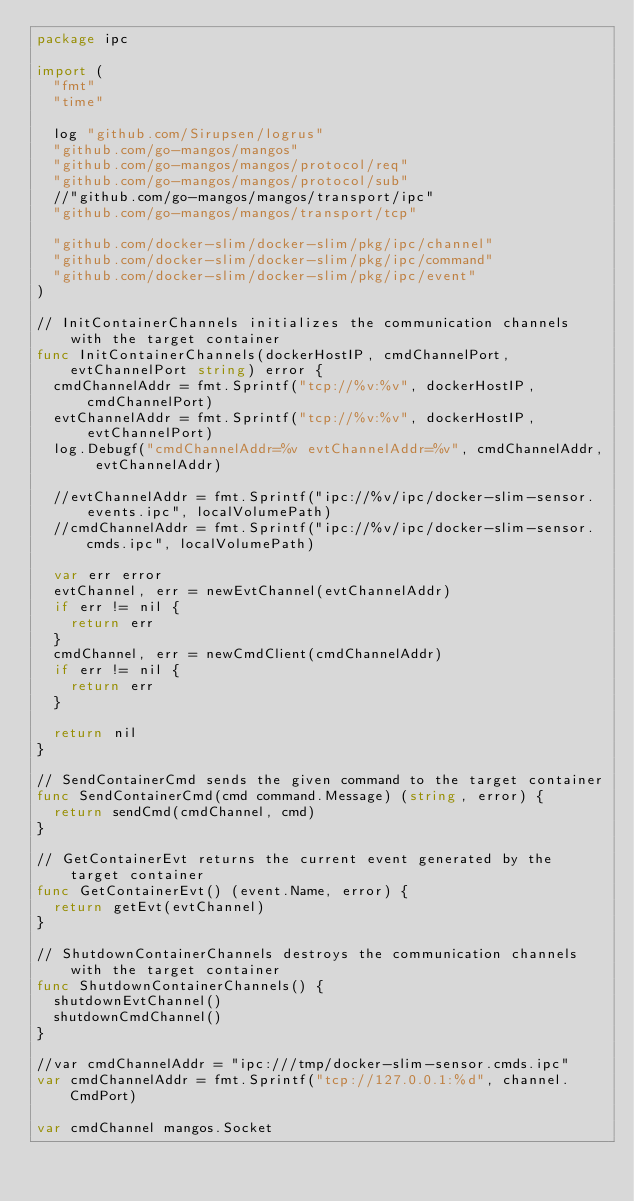<code> <loc_0><loc_0><loc_500><loc_500><_Go_>package ipc

import (
	"fmt"
	"time"

	log "github.com/Sirupsen/logrus"
	"github.com/go-mangos/mangos"
	"github.com/go-mangos/mangos/protocol/req"
	"github.com/go-mangos/mangos/protocol/sub"
	//"github.com/go-mangos/mangos/transport/ipc"
	"github.com/go-mangos/mangos/transport/tcp"

	"github.com/docker-slim/docker-slim/pkg/ipc/channel"
	"github.com/docker-slim/docker-slim/pkg/ipc/command"
	"github.com/docker-slim/docker-slim/pkg/ipc/event"
)

// InitContainerChannels initializes the communication channels with the target container
func InitContainerChannels(dockerHostIP, cmdChannelPort, evtChannelPort string) error {
	cmdChannelAddr = fmt.Sprintf("tcp://%v:%v", dockerHostIP, cmdChannelPort)
	evtChannelAddr = fmt.Sprintf("tcp://%v:%v", dockerHostIP, evtChannelPort)
	log.Debugf("cmdChannelAddr=%v evtChannelAddr=%v", cmdChannelAddr, evtChannelAddr)

	//evtChannelAddr = fmt.Sprintf("ipc://%v/ipc/docker-slim-sensor.events.ipc", localVolumePath)
	//cmdChannelAddr = fmt.Sprintf("ipc://%v/ipc/docker-slim-sensor.cmds.ipc", localVolumePath)

	var err error
	evtChannel, err = newEvtChannel(evtChannelAddr)
	if err != nil {
		return err
	}
	cmdChannel, err = newCmdClient(cmdChannelAddr)
	if err != nil {
		return err
	}

	return nil
}

// SendContainerCmd sends the given command to the target container
func SendContainerCmd(cmd command.Message) (string, error) {
	return sendCmd(cmdChannel, cmd)
}

// GetContainerEvt returns the current event generated by the target container
func GetContainerEvt() (event.Name, error) {
	return getEvt(evtChannel)
}

// ShutdownContainerChannels destroys the communication channels with the target container
func ShutdownContainerChannels() {
	shutdownEvtChannel()
	shutdownCmdChannel()
}

//var cmdChannelAddr = "ipc:///tmp/docker-slim-sensor.cmds.ipc"
var cmdChannelAddr = fmt.Sprintf("tcp://127.0.0.1:%d", channel.CmdPort)

var cmdChannel mangos.Socket
</code> 